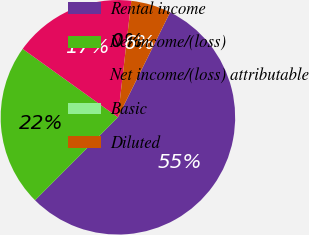Convert chart to OTSL. <chart><loc_0><loc_0><loc_500><loc_500><pie_chart><fcel>Rental income<fcel>Net income/(loss)<fcel>Net income/(loss) attributable<fcel>Basic<fcel>Diluted<nl><fcel>55.15%<fcel>22.42%<fcel>16.91%<fcel>0.0%<fcel>5.52%<nl></chart> 